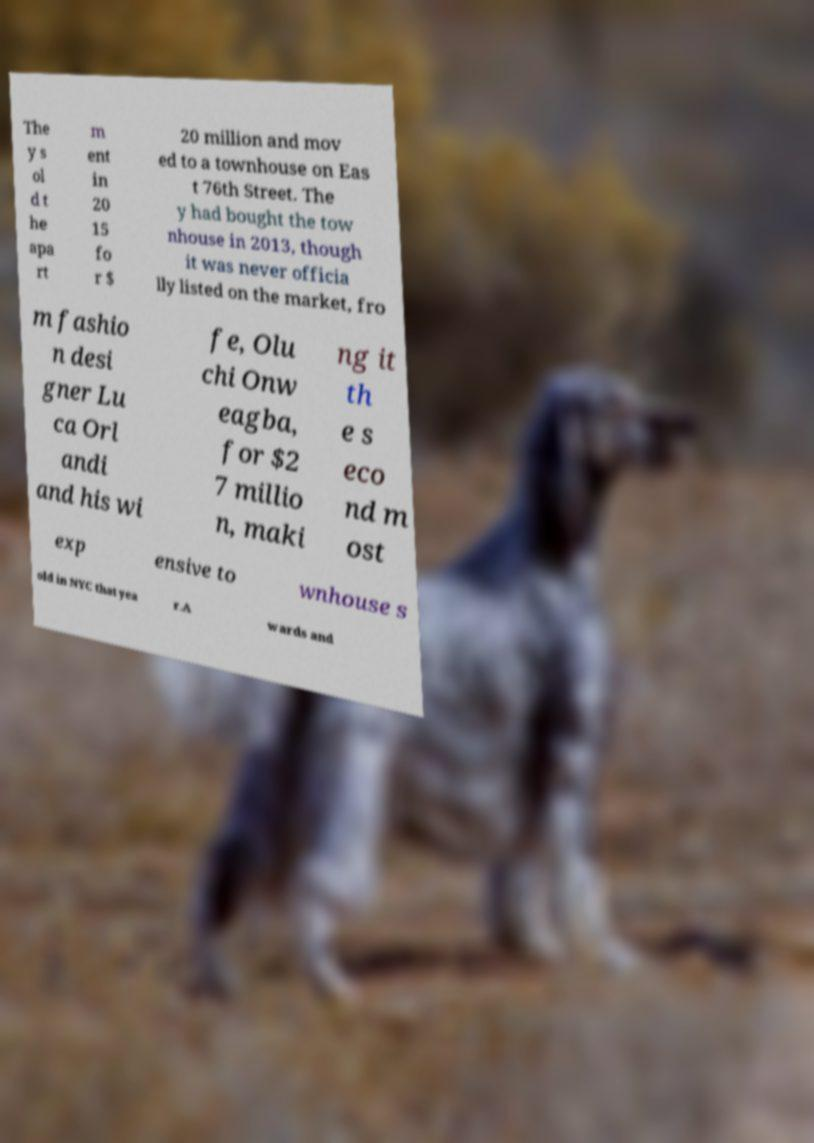Can you accurately transcribe the text from the provided image for me? The y s ol d t he apa rt m ent in 20 15 fo r $ 20 million and mov ed to a townhouse on Eas t 76th Street. The y had bought the tow nhouse in 2013, though it was never officia lly listed on the market, fro m fashio n desi gner Lu ca Orl andi and his wi fe, Olu chi Onw eagba, for $2 7 millio n, maki ng it th e s eco nd m ost exp ensive to wnhouse s old in NYC that yea r.A wards and 